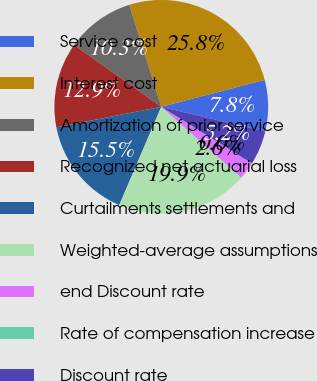Convert chart. <chart><loc_0><loc_0><loc_500><loc_500><pie_chart><fcel>Service cost<fcel>Interest cost<fcel>Amortization of prior service<fcel>Recognized net actuarial loss<fcel>Curtailments settlements and<fcel>Weighted-average assumptions<fcel>end Discount rate<fcel>Rate of compensation increase<fcel>Discount rate<nl><fcel>7.76%<fcel>25.79%<fcel>10.33%<fcel>12.91%<fcel>15.49%<fcel>19.9%<fcel>2.61%<fcel>0.03%<fcel>5.18%<nl></chart> 